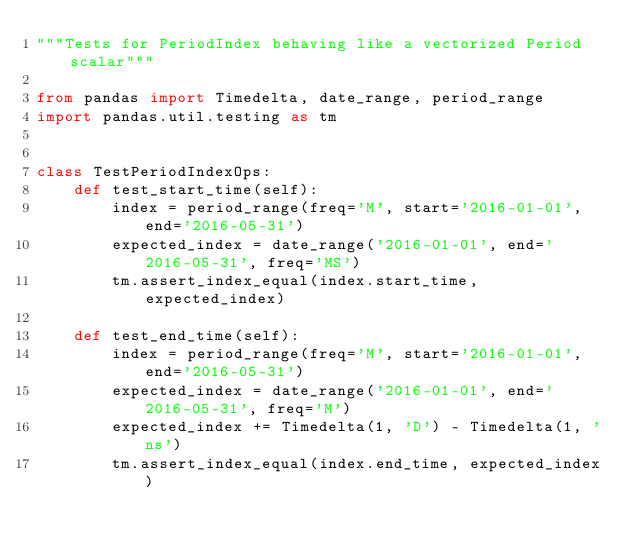<code> <loc_0><loc_0><loc_500><loc_500><_Python_>"""Tests for PeriodIndex behaving like a vectorized Period scalar"""

from pandas import Timedelta, date_range, period_range
import pandas.util.testing as tm


class TestPeriodIndexOps:
    def test_start_time(self):
        index = period_range(freq='M', start='2016-01-01', end='2016-05-31')
        expected_index = date_range('2016-01-01', end='2016-05-31', freq='MS')
        tm.assert_index_equal(index.start_time, expected_index)

    def test_end_time(self):
        index = period_range(freq='M', start='2016-01-01', end='2016-05-31')
        expected_index = date_range('2016-01-01', end='2016-05-31', freq='M')
        expected_index += Timedelta(1, 'D') - Timedelta(1, 'ns')
        tm.assert_index_equal(index.end_time, expected_index)
</code> 